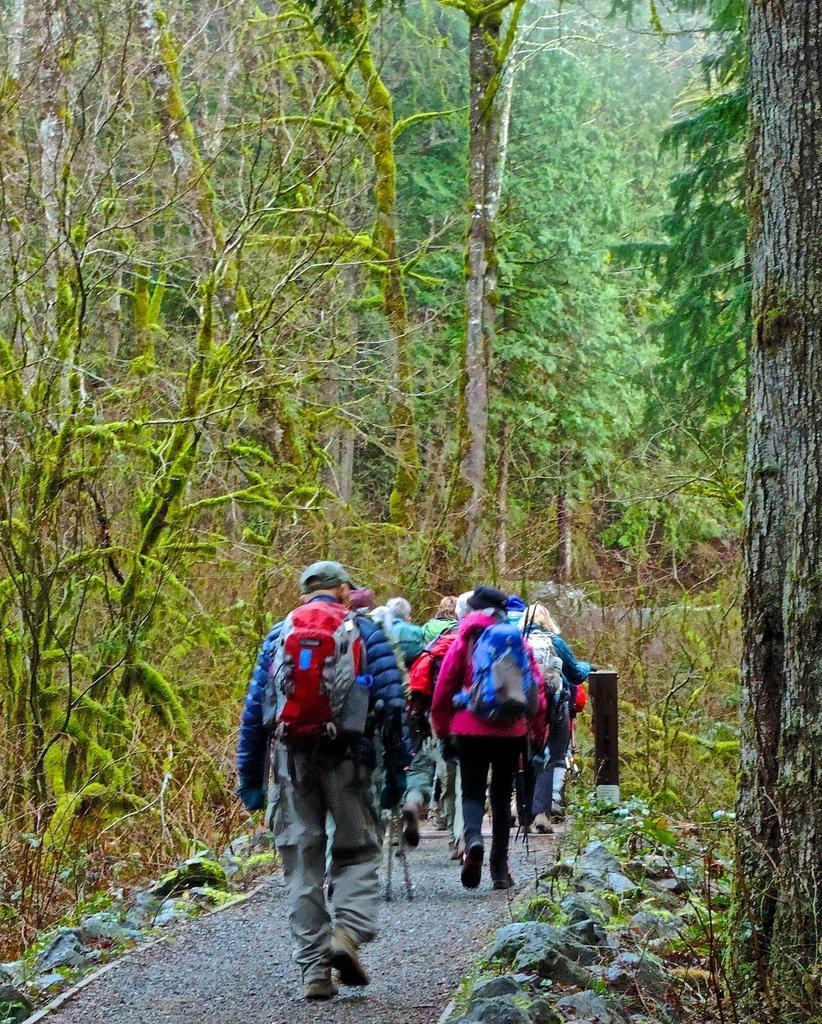In one or two sentences, can you explain what this image depicts? In this picture there people walking and carrying bags and we can see plants, trees and pole. 